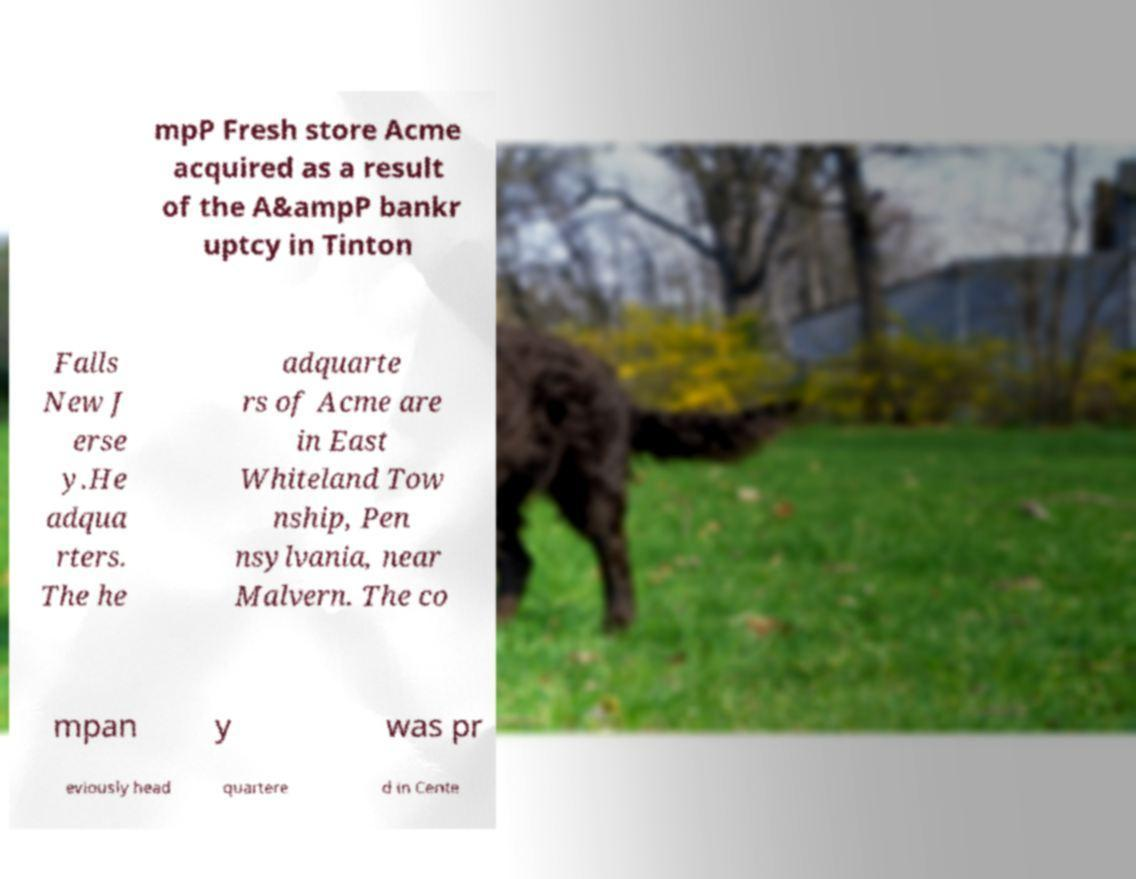Please read and relay the text visible in this image. What does it say? mpP Fresh store Acme acquired as a result of the A&ampP bankr uptcy in Tinton Falls New J erse y.He adqua rters. The he adquarte rs of Acme are in East Whiteland Tow nship, Pen nsylvania, near Malvern. The co mpan y was pr eviously head quartere d in Cente 